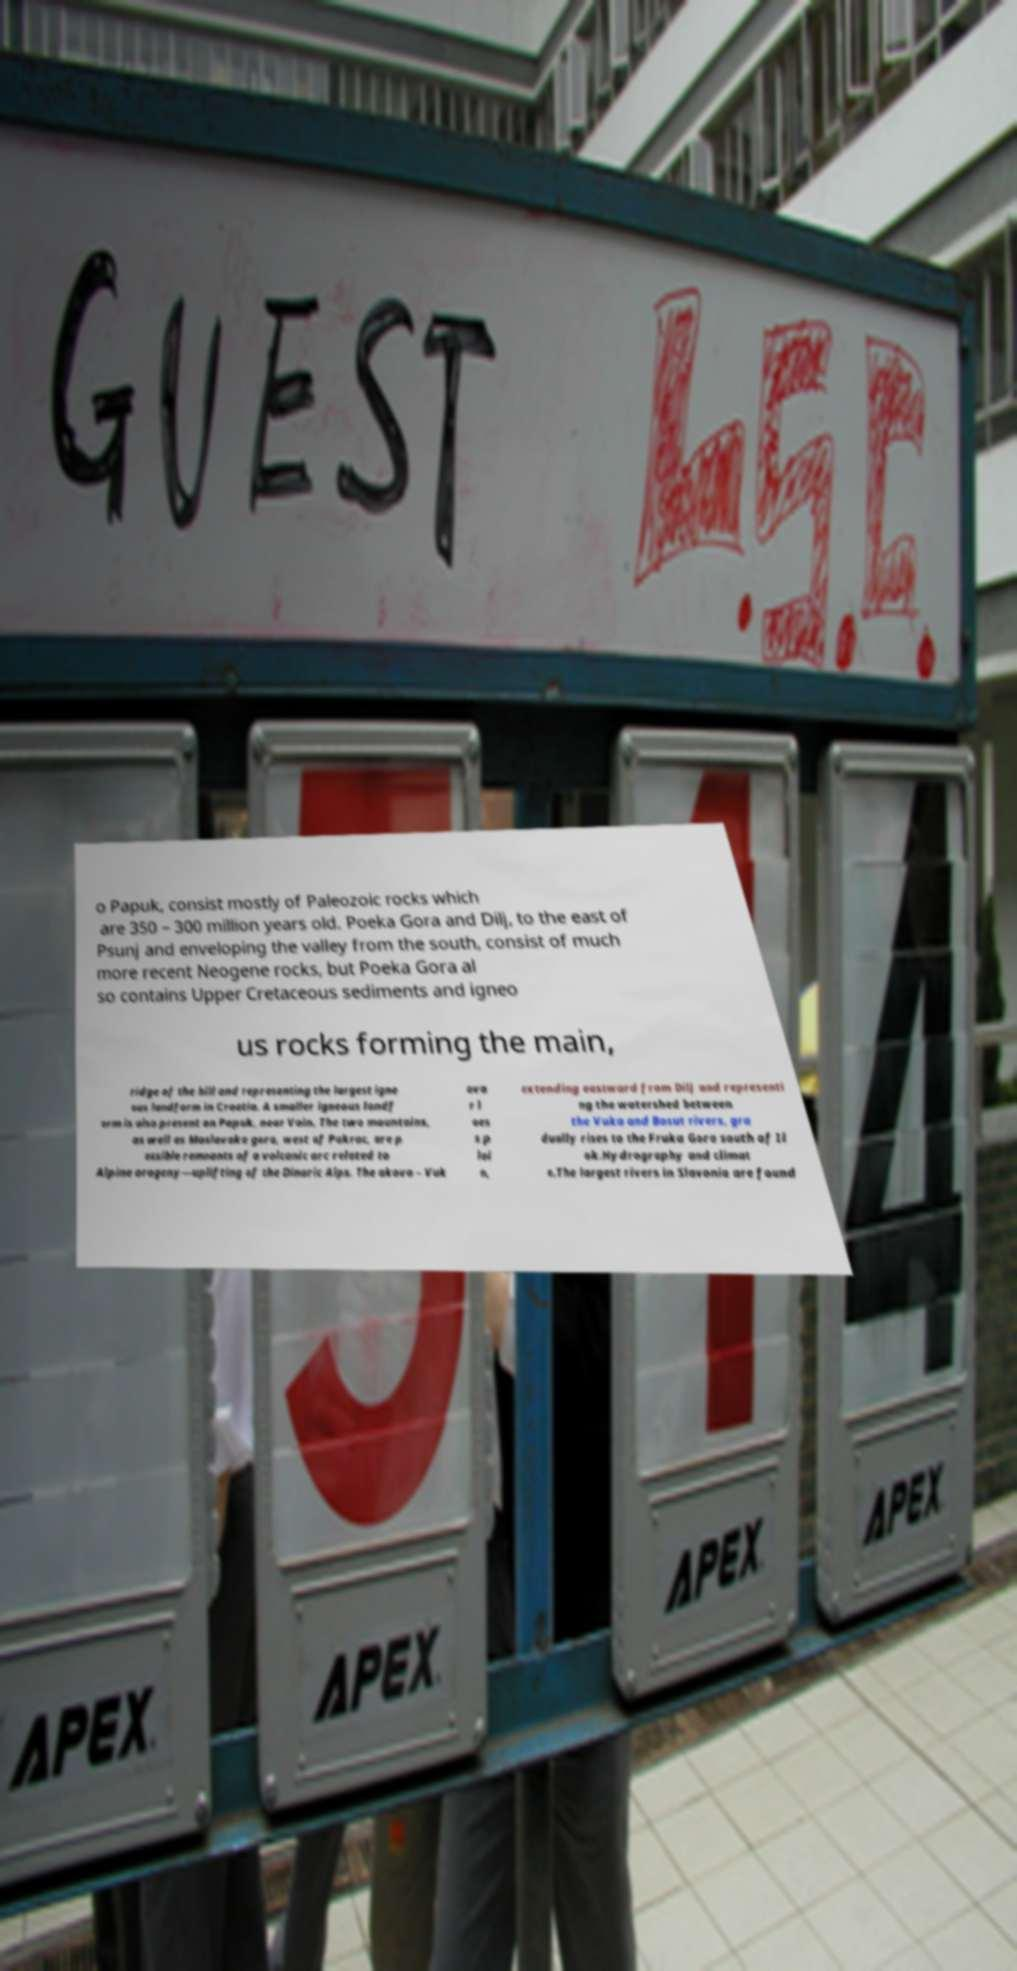Can you read and provide the text displayed in the image?This photo seems to have some interesting text. Can you extract and type it out for me? o Papuk, consist mostly of Paleozoic rocks which are 350 – 300 million years old. Poeka Gora and Dilj, to the east of Psunj and enveloping the valley from the south, consist of much more recent Neogene rocks, but Poeka Gora al so contains Upper Cretaceous sediments and igneo us rocks forming the main, ridge of the hill and representing the largest igne ous landform in Croatia. A smaller igneous landf orm is also present on Papuk, near Voin. The two mountains, as well as Moslavaka gora, west of Pakrac, are p ossible remnants of a volcanic arc related to Alpine orogeny—uplifting of the Dinaric Alps. The akovo – Vuk ova r l oes s p lai n, extending eastward from Dilj and representi ng the watershed between the Vuka and Bosut rivers, gra dually rises to the Fruka Gora south of Il ok.Hydrography and climat e.The largest rivers in Slavonia are found 